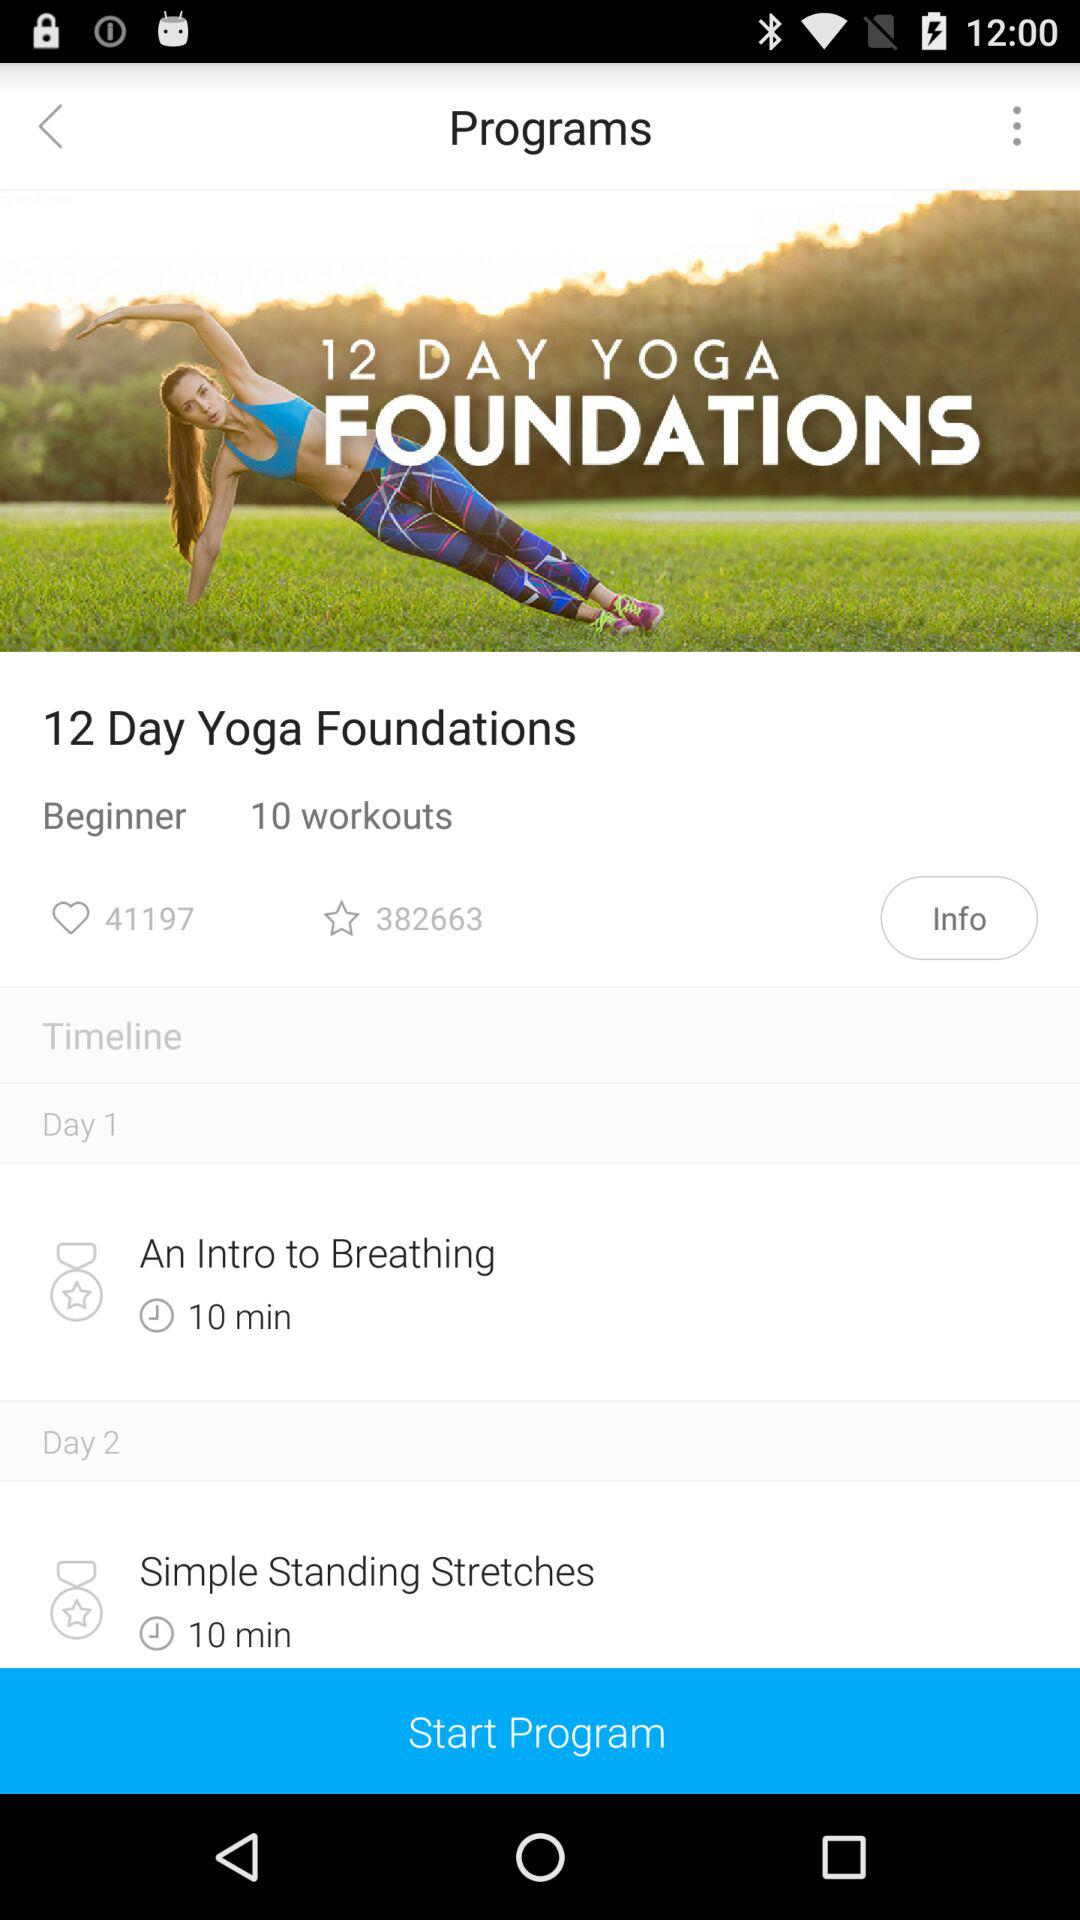How many workouts in total are there in the program? There are 10 workouts in total. 